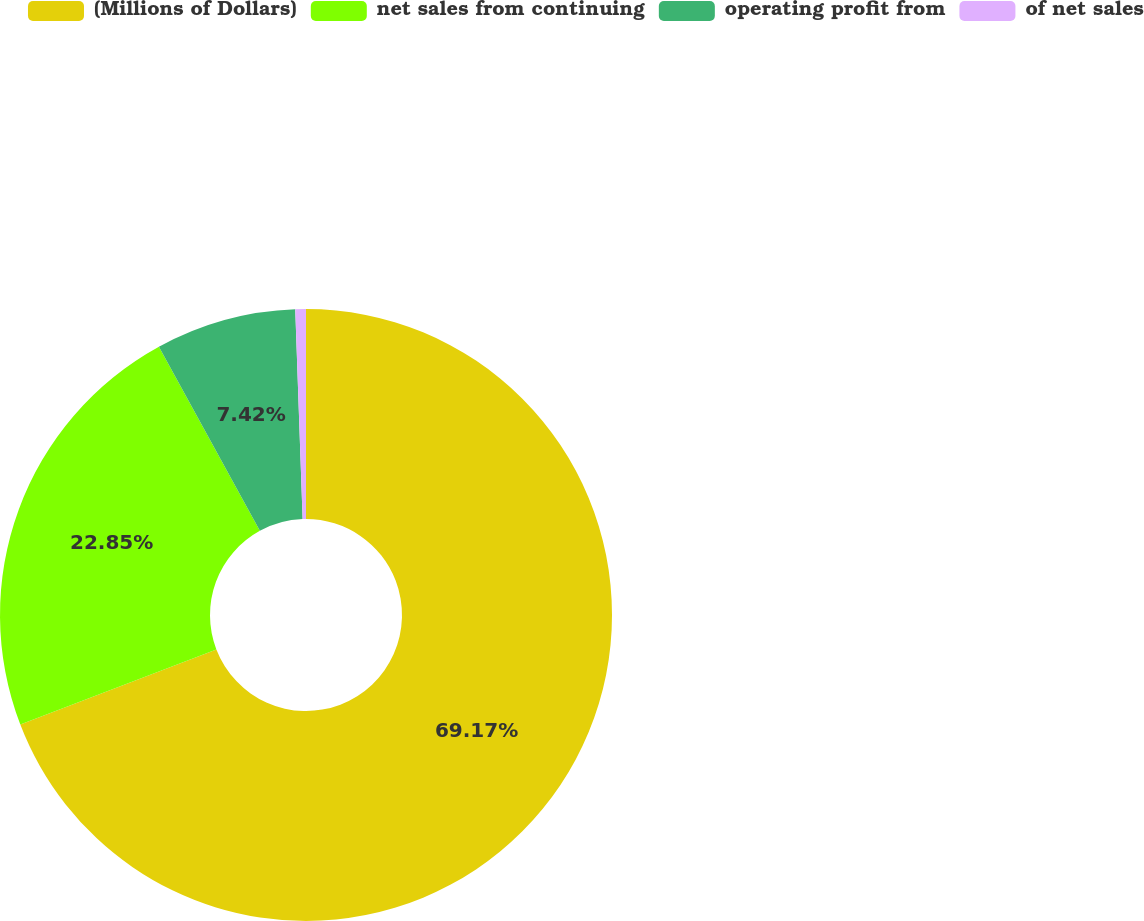<chart> <loc_0><loc_0><loc_500><loc_500><pie_chart><fcel>(Millions of Dollars)<fcel>net sales from continuing<fcel>operating profit from<fcel>of net sales<nl><fcel>69.17%<fcel>22.85%<fcel>7.42%<fcel>0.56%<nl></chart> 